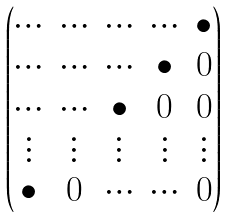<formula> <loc_0><loc_0><loc_500><loc_500>\begin{pmatrix} \hdots & \hdots & \hdots & \hdots & \bullet \\ \hdots & \hdots & \hdots & \bullet & 0 \\ \hdots & \hdots & \bullet & 0 & 0 \\ \vdots & \vdots & \vdots & \vdots & \vdots \\ \bullet & 0 & \hdots & \hdots & 0 \end{pmatrix}</formula> 